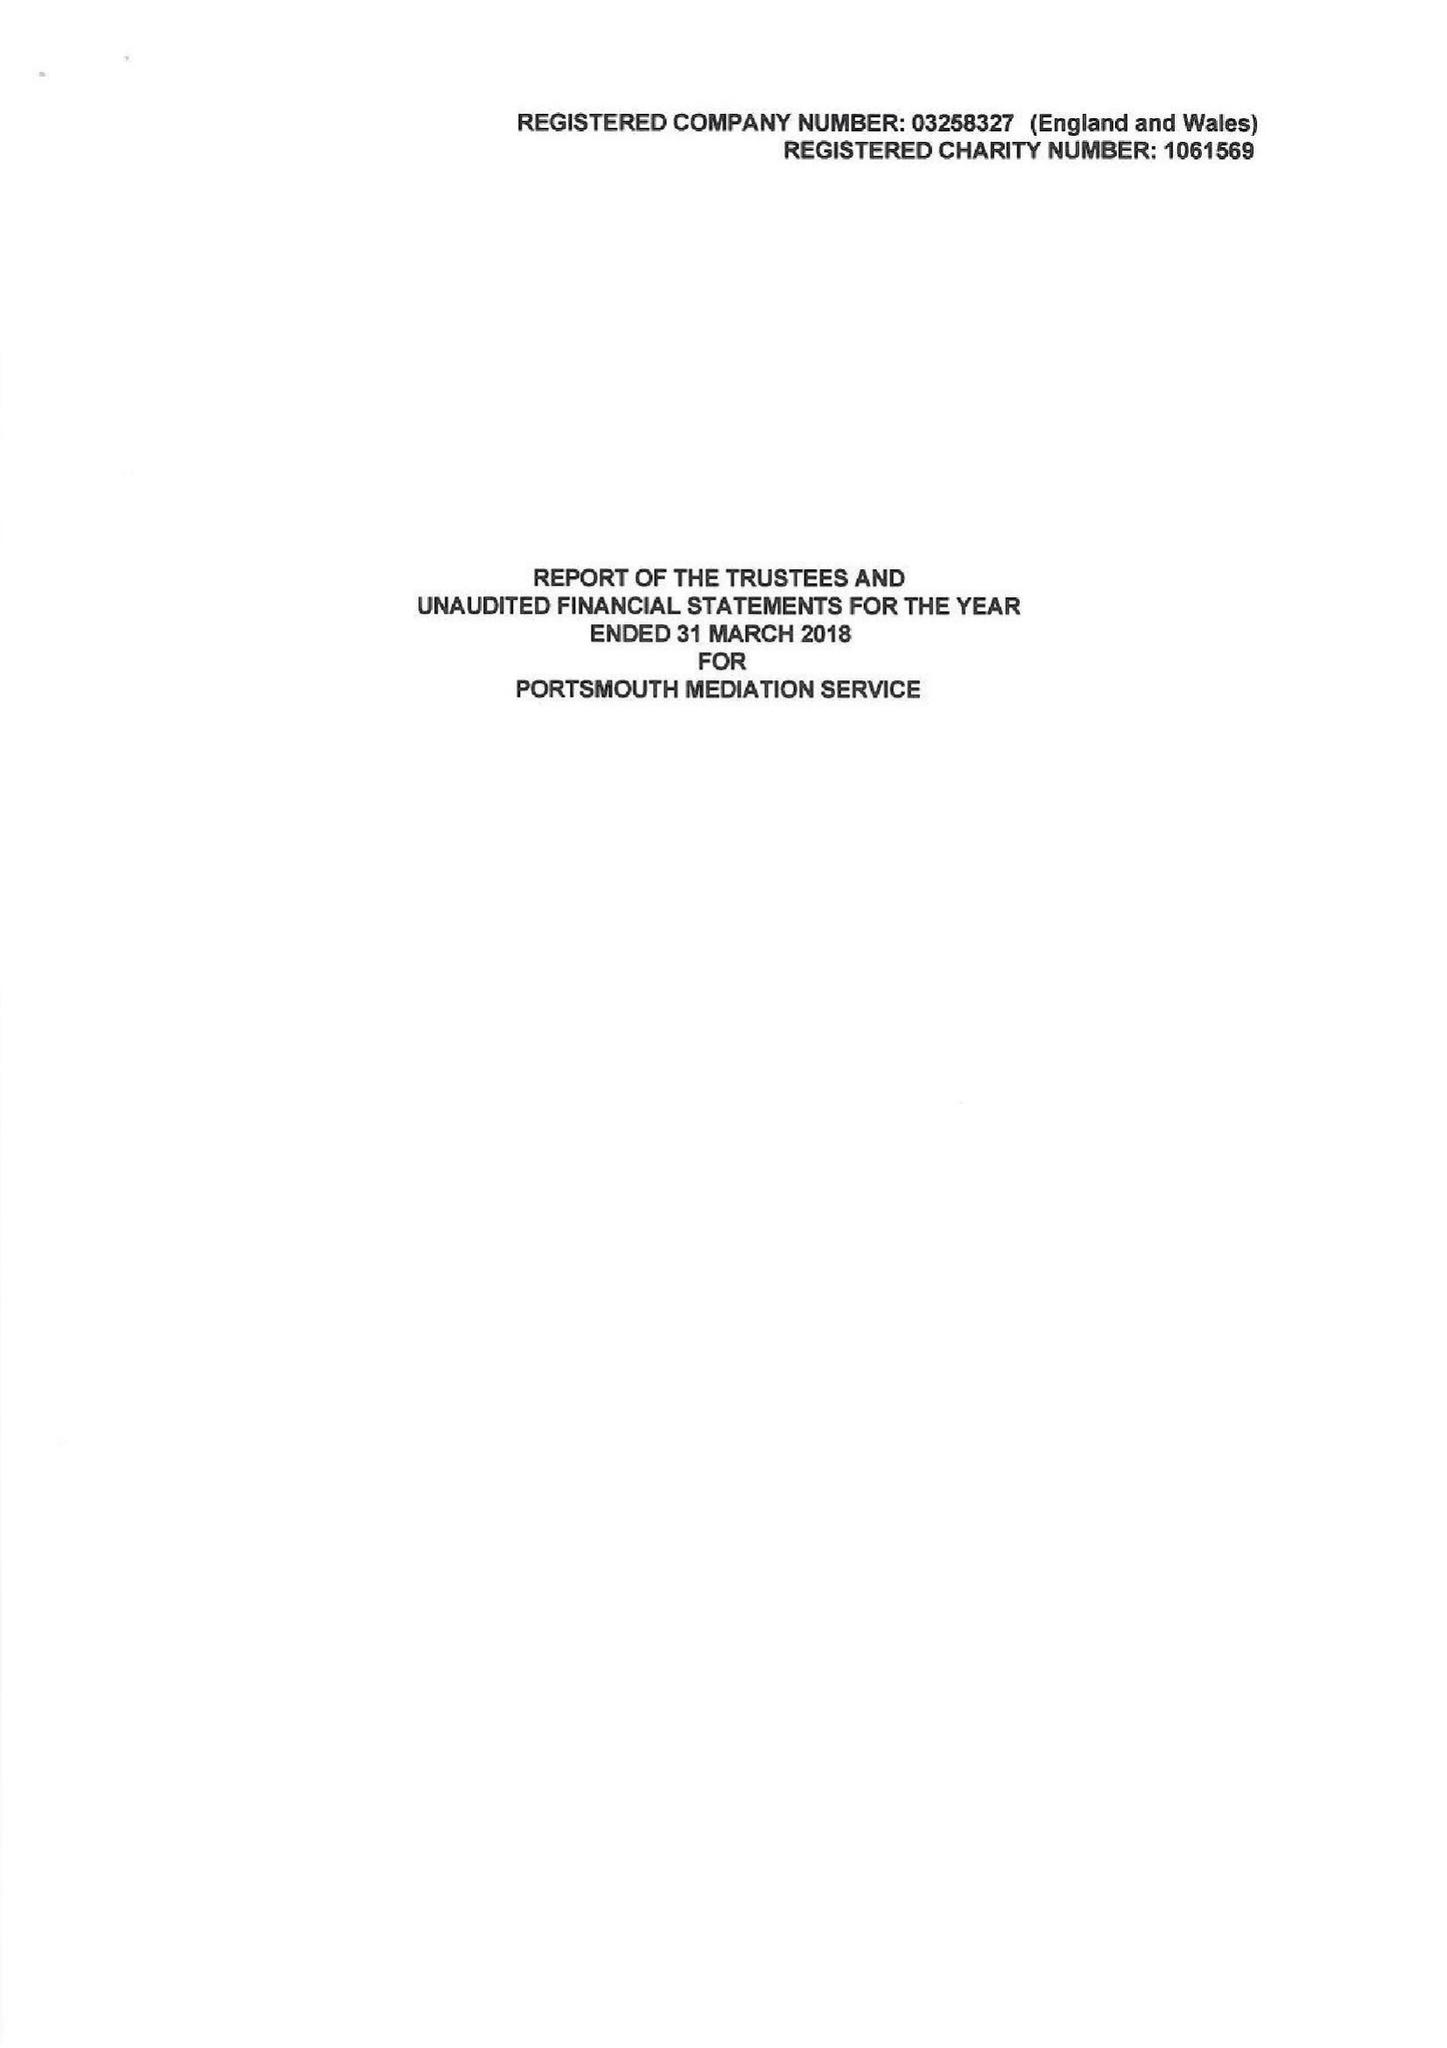What is the value for the spending_annually_in_british_pounds?
Answer the question using a single word or phrase. 156562.00 